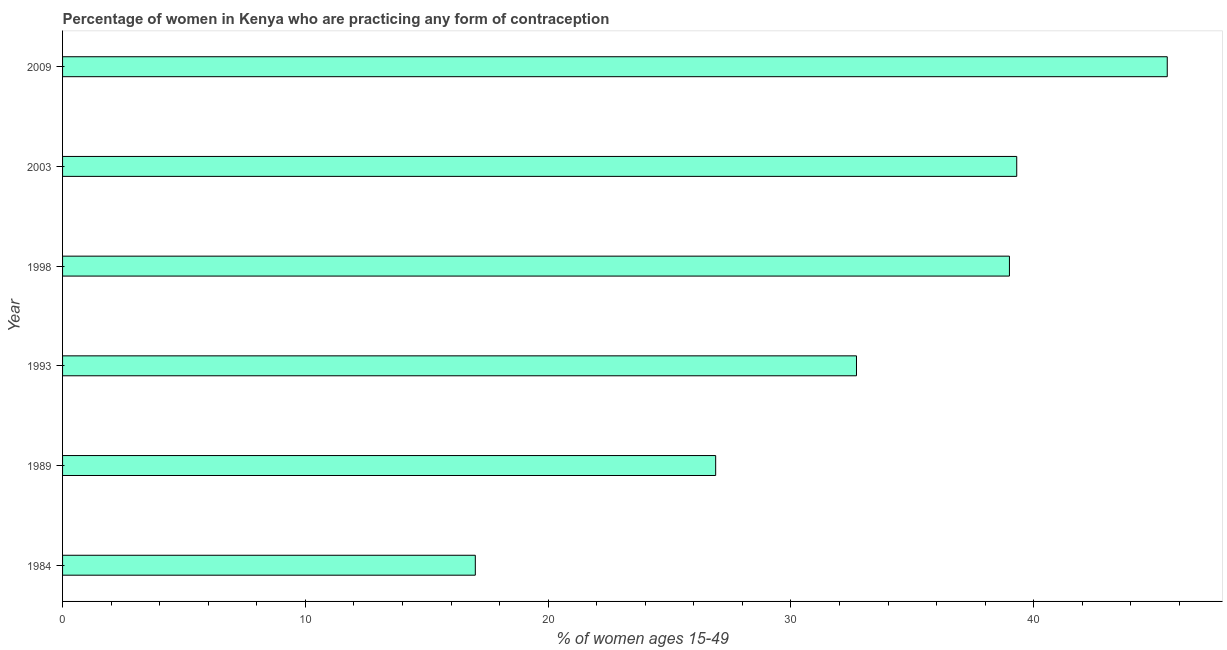What is the title of the graph?
Offer a very short reply. Percentage of women in Kenya who are practicing any form of contraception. What is the label or title of the X-axis?
Ensure brevity in your answer.  % of women ages 15-49. Across all years, what is the maximum contraceptive prevalence?
Make the answer very short. 45.5. In which year was the contraceptive prevalence minimum?
Provide a short and direct response. 1984. What is the sum of the contraceptive prevalence?
Offer a very short reply. 200.4. What is the average contraceptive prevalence per year?
Offer a terse response. 33.4. What is the median contraceptive prevalence?
Provide a short and direct response. 35.85. What is the ratio of the contraceptive prevalence in 1993 to that in 2003?
Offer a very short reply. 0.83. Is the contraceptive prevalence in 1984 less than that in 1993?
Ensure brevity in your answer.  Yes. Is the difference between the contraceptive prevalence in 1989 and 2009 greater than the difference between any two years?
Your response must be concise. No. What is the difference between the highest and the second highest contraceptive prevalence?
Provide a short and direct response. 6.2. Is the sum of the contraceptive prevalence in 1989 and 2003 greater than the maximum contraceptive prevalence across all years?
Make the answer very short. Yes. What is the difference between the highest and the lowest contraceptive prevalence?
Keep it short and to the point. 28.5. How many years are there in the graph?
Keep it short and to the point. 6. What is the difference between two consecutive major ticks on the X-axis?
Provide a succinct answer. 10. What is the % of women ages 15-49 of 1984?
Give a very brief answer. 17. What is the % of women ages 15-49 in 1989?
Provide a short and direct response. 26.9. What is the % of women ages 15-49 of 1993?
Your answer should be very brief. 32.7. What is the % of women ages 15-49 in 1998?
Offer a very short reply. 39. What is the % of women ages 15-49 in 2003?
Make the answer very short. 39.3. What is the % of women ages 15-49 of 2009?
Offer a very short reply. 45.5. What is the difference between the % of women ages 15-49 in 1984 and 1993?
Your answer should be very brief. -15.7. What is the difference between the % of women ages 15-49 in 1984 and 2003?
Make the answer very short. -22.3. What is the difference between the % of women ages 15-49 in 1984 and 2009?
Ensure brevity in your answer.  -28.5. What is the difference between the % of women ages 15-49 in 1989 and 1993?
Your response must be concise. -5.8. What is the difference between the % of women ages 15-49 in 1989 and 1998?
Your response must be concise. -12.1. What is the difference between the % of women ages 15-49 in 1989 and 2003?
Provide a short and direct response. -12.4. What is the difference between the % of women ages 15-49 in 1989 and 2009?
Offer a terse response. -18.6. What is the difference between the % of women ages 15-49 in 1993 and 2003?
Offer a terse response. -6.6. What is the ratio of the % of women ages 15-49 in 1984 to that in 1989?
Make the answer very short. 0.63. What is the ratio of the % of women ages 15-49 in 1984 to that in 1993?
Give a very brief answer. 0.52. What is the ratio of the % of women ages 15-49 in 1984 to that in 1998?
Offer a terse response. 0.44. What is the ratio of the % of women ages 15-49 in 1984 to that in 2003?
Your answer should be very brief. 0.43. What is the ratio of the % of women ages 15-49 in 1984 to that in 2009?
Provide a succinct answer. 0.37. What is the ratio of the % of women ages 15-49 in 1989 to that in 1993?
Make the answer very short. 0.82. What is the ratio of the % of women ages 15-49 in 1989 to that in 1998?
Your answer should be compact. 0.69. What is the ratio of the % of women ages 15-49 in 1989 to that in 2003?
Offer a terse response. 0.68. What is the ratio of the % of women ages 15-49 in 1989 to that in 2009?
Your answer should be compact. 0.59. What is the ratio of the % of women ages 15-49 in 1993 to that in 1998?
Keep it short and to the point. 0.84. What is the ratio of the % of women ages 15-49 in 1993 to that in 2003?
Your answer should be very brief. 0.83. What is the ratio of the % of women ages 15-49 in 1993 to that in 2009?
Make the answer very short. 0.72. What is the ratio of the % of women ages 15-49 in 1998 to that in 2003?
Your response must be concise. 0.99. What is the ratio of the % of women ages 15-49 in 1998 to that in 2009?
Ensure brevity in your answer.  0.86. What is the ratio of the % of women ages 15-49 in 2003 to that in 2009?
Keep it short and to the point. 0.86. 